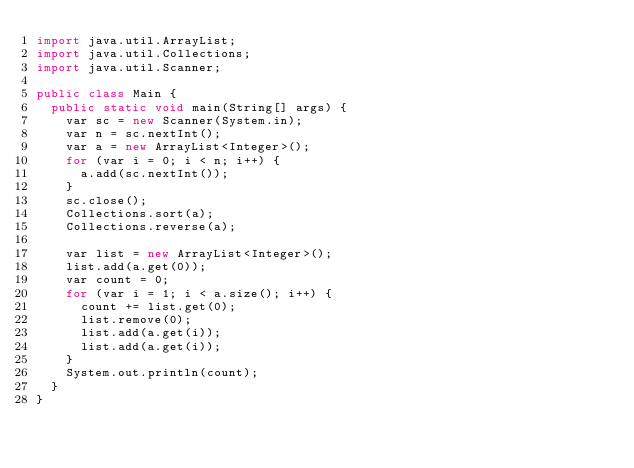Convert code to text. <code><loc_0><loc_0><loc_500><loc_500><_Java_>import java.util.ArrayList;
import java.util.Collections;
import java.util.Scanner;

public class Main {
	public static void main(String[] args) {
		var sc = new Scanner(System.in);
		var n = sc.nextInt();
		var a = new ArrayList<Integer>();
		for (var i = 0; i < n; i++) {
			a.add(sc.nextInt());
		}
		sc.close();
		Collections.sort(a);
		Collections.reverse(a);

		var list = new ArrayList<Integer>();
		list.add(a.get(0));
		var count = 0;
		for (var i = 1; i < a.size(); i++) {
			count += list.get(0);
			list.remove(0);
			list.add(a.get(i));
			list.add(a.get(i));
		}
		System.out.println(count);
	}
}</code> 